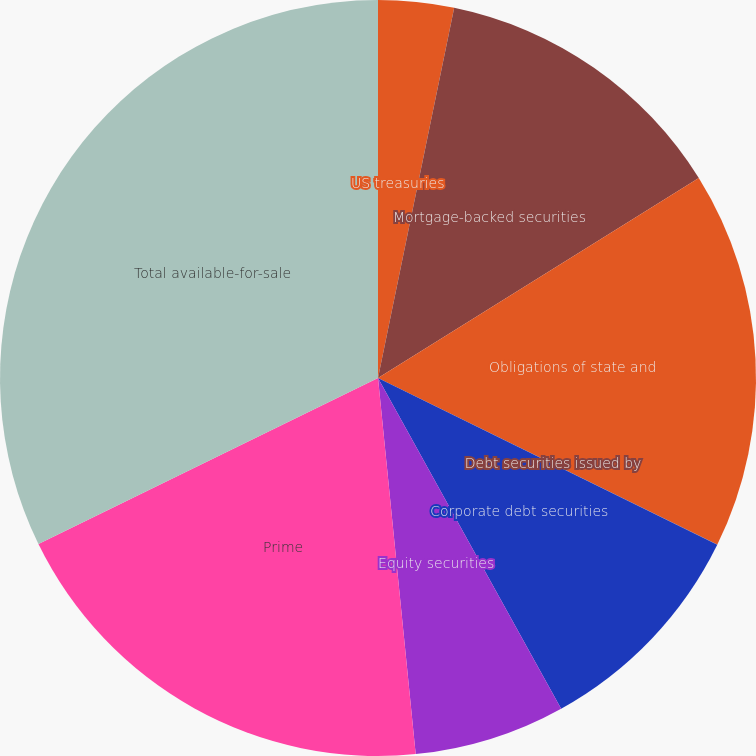Convert chart to OTSL. <chart><loc_0><loc_0><loc_500><loc_500><pie_chart><fcel>US treasuries<fcel>Mortgage-backed securities<fcel>Obligations of state and<fcel>Debt securities issued by<fcel>Corporate debt securities<fcel>Equity securities<fcel>Prime<fcel>Total available-for-sale<nl><fcel>3.23%<fcel>12.9%<fcel>16.13%<fcel>0.01%<fcel>9.68%<fcel>6.46%<fcel>19.35%<fcel>32.24%<nl></chart> 